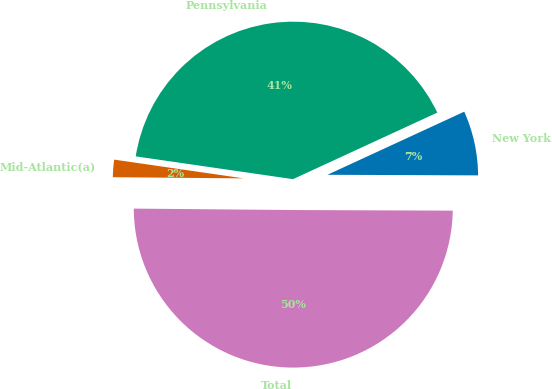<chart> <loc_0><loc_0><loc_500><loc_500><pie_chart><fcel>New York<fcel>Pennsylvania<fcel>Mid-Atlantic(a)<fcel>Total<nl><fcel>6.94%<fcel>40.83%<fcel>2.15%<fcel>50.08%<nl></chart> 